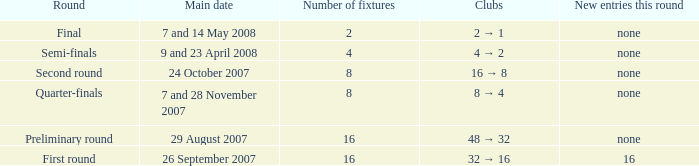What is the New entries this round when the round is the semi-finals? None. 